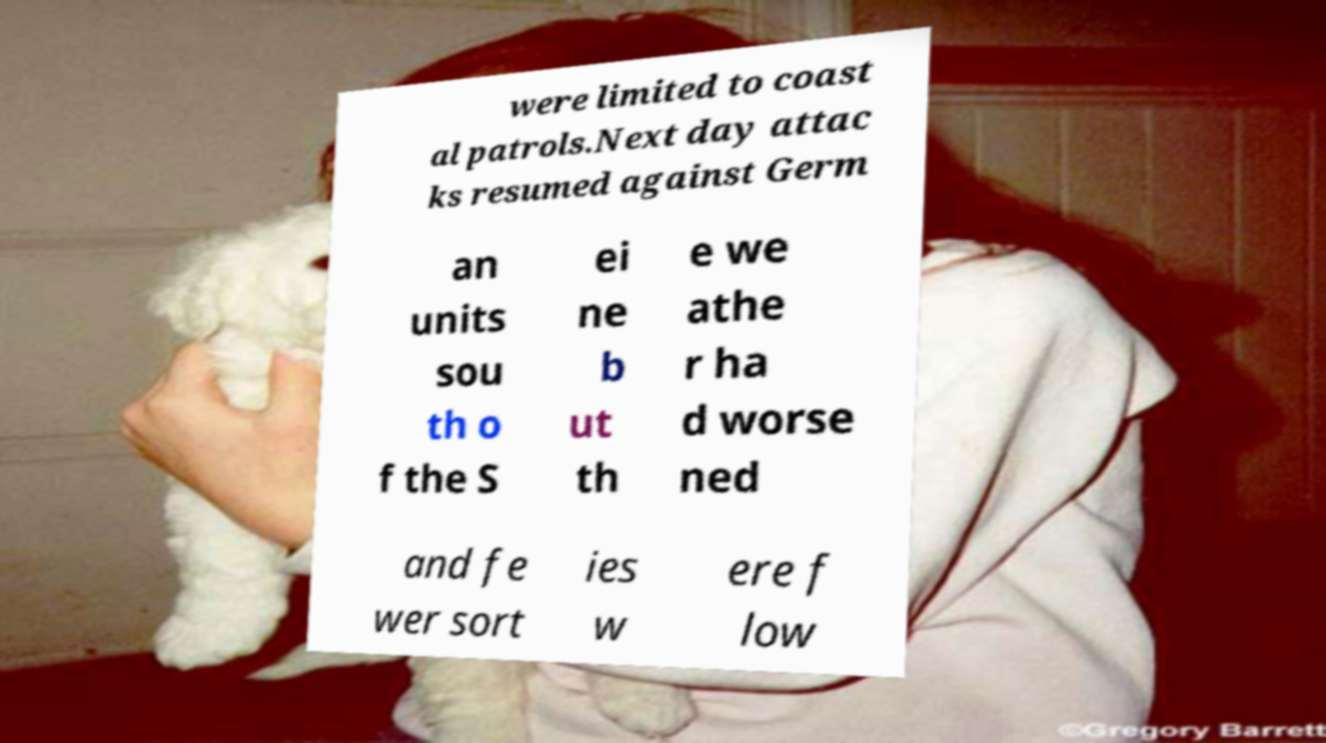What messages or text are displayed in this image? I need them in a readable, typed format. were limited to coast al patrols.Next day attac ks resumed against Germ an units sou th o f the S ei ne b ut th e we athe r ha d worse ned and fe wer sort ies w ere f low 